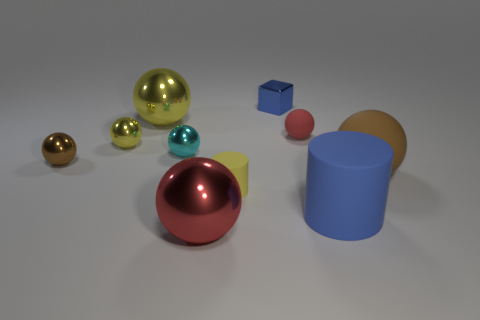Subtract all cyan metallic balls. How many balls are left? 6 Subtract all blue cylinders. How many cylinders are left? 1 Subtract all cubes. How many objects are left? 9 Add 7 big balls. How many big balls are left? 10 Add 1 big matte balls. How many big matte balls exist? 2 Subtract 0 purple spheres. How many objects are left? 10 Subtract 3 spheres. How many spheres are left? 4 Subtract all blue cylinders. Subtract all gray cubes. How many cylinders are left? 1 Subtract all purple cylinders. How many green cubes are left? 0 Subtract all yellow matte cylinders. Subtract all blue matte cylinders. How many objects are left? 8 